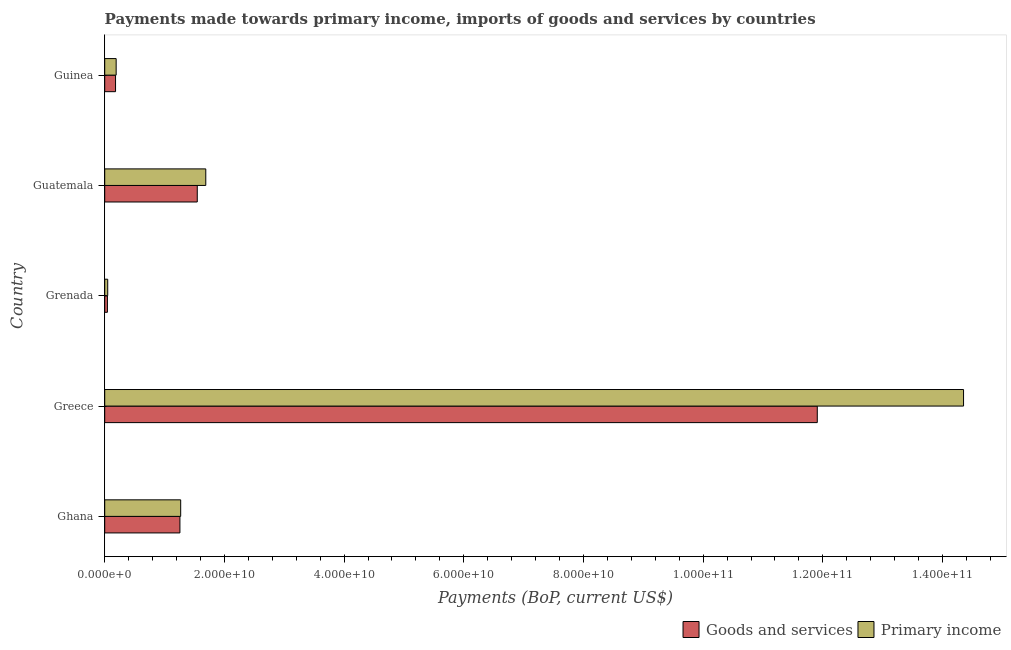How many different coloured bars are there?
Offer a terse response. 2. Are the number of bars per tick equal to the number of legend labels?
Your answer should be compact. Yes. Are the number of bars on each tick of the Y-axis equal?
Provide a short and direct response. Yes. How many bars are there on the 3rd tick from the bottom?
Ensure brevity in your answer.  2. In how many cases, is the number of bars for a given country not equal to the number of legend labels?
Your answer should be compact. 0. What is the payments made towards primary income in Greece?
Your response must be concise. 1.44e+11. Across all countries, what is the maximum payments made towards primary income?
Provide a succinct answer. 1.44e+11. Across all countries, what is the minimum payments made towards goods and services?
Offer a very short reply. 4.52e+08. In which country was the payments made towards primary income minimum?
Give a very brief answer. Grenada. What is the total payments made towards primary income in the graph?
Ensure brevity in your answer.  1.76e+11. What is the difference between the payments made towards primary income in Ghana and that in Grenada?
Your response must be concise. 1.22e+1. What is the difference between the payments made towards goods and services in Grenada and the payments made towards primary income in Greece?
Your answer should be compact. -1.43e+11. What is the average payments made towards primary income per country?
Make the answer very short. 3.51e+1. What is the difference between the payments made towards primary income and payments made towards goods and services in Guatemala?
Provide a short and direct response. 1.42e+09. What is the ratio of the payments made towards primary income in Greece to that in Guinea?
Your response must be concise. 75.08. Is the difference between the payments made towards goods and services in Ghana and Guatemala greater than the difference between the payments made towards primary income in Ghana and Guatemala?
Provide a short and direct response. Yes. What is the difference between the highest and the second highest payments made towards goods and services?
Provide a succinct answer. 1.04e+11. What is the difference between the highest and the lowest payments made towards primary income?
Ensure brevity in your answer.  1.43e+11. What does the 1st bar from the top in Ghana represents?
Ensure brevity in your answer.  Primary income. What does the 2nd bar from the bottom in Guatemala represents?
Give a very brief answer. Primary income. How many bars are there?
Offer a terse response. 10. How many legend labels are there?
Offer a terse response. 2. What is the title of the graph?
Offer a terse response. Payments made towards primary income, imports of goods and services by countries. What is the label or title of the X-axis?
Your response must be concise. Payments (BoP, current US$). What is the label or title of the Y-axis?
Offer a very short reply. Country. What is the Payments (BoP, current US$) of Goods and services in Ghana?
Ensure brevity in your answer.  1.26e+1. What is the Payments (BoP, current US$) in Primary income in Ghana?
Provide a succinct answer. 1.27e+1. What is the Payments (BoP, current US$) in Goods and services in Greece?
Provide a short and direct response. 1.19e+11. What is the Payments (BoP, current US$) in Primary income in Greece?
Offer a very short reply. 1.44e+11. What is the Payments (BoP, current US$) in Goods and services in Grenada?
Ensure brevity in your answer.  4.52e+08. What is the Payments (BoP, current US$) in Primary income in Grenada?
Ensure brevity in your answer.  5.03e+08. What is the Payments (BoP, current US$) of Goods and services in Guatemala?
Your answer should be very brief. 1.55e+1. What is the Payments (BoP, current US$) of Primary income in Guatemala?
Your response must be concise. 1.69e+1. What is the Payments (BoP, current US$) of Goods and services in Guinea?
Give a very brief answer. 1.81e+09. What is the Payments (BoP, current US$) in Primary income in Guinea?
Offer a very short reply. 1.91e+09. Across all countries, what is the maximum Payments (BoP, current US$) of Goods and services?
Offer a very short reply. 1.19e+11. Across all countries, what is the maximum Payments (BoP, current US$) in Primary income?
Your answer should be very brief. 1.44e+11. Across all countries, what is the minimum Payments (BoP, current US$) of Goods and services?
Your answer should be very brief. 4.52e+08. Across all countries, what is the minimum Payments (BoP, current US$) of Primary income?
Provide a short and direct response. 5.03e+08. What is the total Payments (BoP, current US$) in Goods and services in the graph?
Keep it short and to the point. 1.49e+11. What is the total Payments (BoP, current US$) in Primary income in the graph?
Make the answer very short. 1.76e+11. What is the difference between the Payments (BoP, current US$) in Goods and services in Ghana and that in Greece?
Your response must be concise. -1.07e+11. What is the difference between the Payments (BoP, current US$) in Primary income in Ghana and that in Greece?
Make the answer very short. -1.31e+11. What is the difference between the Payments (BoP, current US$) of Goods and services in Ghana and that in Grenada?
Provide a succinct answer. 1.21e+1. What is the difference between the Payments (BoP, current US$) in Primary income in Ghana and that in Grenada?
Provide a succinct answer. 1.22e+1. What is the difference between the Payments (BoP, current US$) in Goods and services in Ghana and that in Guatemala?
Your answer should be compact. -2.90e+09. What is the difference between the Payments (BoP, current US$) in Primary income in Ghana and that in Guatemala?
Your answer should be very brief. -4.19e+09. What is the difference between the Payments (BoP, current US$) in Goods and services in Ghana and that in Guinea?
Keep it short and to the point. 1.08e+1. What is the difference between the Payments (BoP, current US$) of Primary income in Ghana and that in Guinea?
Your answer should be very brief. 1.08e+1. What is the difference between the Payments (BoP, current US$) of Goods and services in Greece and that in Grenada?
Your response must be concise. 1.19e+11. What is the difference between the Payments (BoP, current US$) in Primary income in Greece and that in Grenada?
Offer a very short reply. 1.43e+11. What is the difference between the Payments (BoP, current US$) of Goods and services in Greece and that in Guatemala?
Ensure brevity in your answer.  1.04e+11. What is the difference between the Payments (BoP, current US$) in Primary income in Greece and that in Guatemala?
Keep it short and to the point. 1.27e+11. What is the difference between the Payments (BoP, current US$) of Goods and services in Greece and that in Guinea?
Your answer should be compact. 1.17e+11. What is the difference between the Payments (BoP, current US$) in Primary income in Greece and that in Guinea?
Ensure brevity in your answer.  1.42e+11. What is the difference between the Payments (BoP, current US$) of Goods and services in Grenada and that in Guatemala?
Your response must be concise. -1.50e+1. What is the difference between the Payments (BoP, current US$) of Primary income in Grenada and that in Guatemala?
Ensure brevity in your answer.  -1.64e+1. What is the difference between the Payments (BoP, current US$) in Goods and services in Grenada and that in Guinea?
Make the answer very short. -1.36e+09. What is the difference between the Payments (BoP, current US$) in Primary income in Grenada and that in Guinea?
Offer a very short reply. -1.41e+09. What is the difference between the Payments (BoP, current US$) in Goods and services in Guatemala and that in Guinea?
Your answer should be compact. 1.37e+1. What is the difference between the Payments (BoP, current US$) of Primary income in Guatemala and that in Guinea?
Provide a short and direct response. 1.50e+1. What is the difference between the Payments (BoP, current US$) of Goods and services in Ghana and the Payments (BoP, current US$) of Primary income in Greece?
Your answer should be very brief. -1.31e+11. What is the difference between the Payments (BoP, current US$) in Goods and services in Ghana and the Payments (BoP, current US$) in Primary income in Grenada?
Make the answer very short. 1.21e+1. What is the difference between the Payments (BoP, current US$) in Goods and services in Ghana and the Payments (BoP, current US$) in Primary income in Guatemala?
Offer a terse response. -4.32e+09. What is the difference between the Payments (BoP, current US$) in Goods and services in Ghana and the Payments (BoP, current US$) in Primary income in Guinea?
Ensure brevity in your answer.  1.07e+1. What is the difference between the Payments (BoP, current US$) of Goods and services in Greece and the Payments (BoP, current US$) of Primary income in Grenada?
Provide a succinct answer. 1.19e+11. What is the difference between the Payments (BoP, current US$) in Goods and services in Greece and the Payments (BoP, current US$) in Primary income in Guatemala?
Your answer should be compact. 1.02e+11. What is the difference between the Payments (BoP, current US$) of Goods and services in Greece and the Payments (BoP, current US$) of Primary income in Guinea?
Make the answer very short. 1.17e+11. What is the difference between the Payments (BoP, current US$) in Goods and services in Grenada and the Payments (BoP, current US$) in Primary income in Guatemala?
Offer a very short reply. -1.64e+1. What is the difference between the Payments (BoP, current US$) of Goods and services in Grenada and the Payments (BoP, current US$) of Primary income in Guinea?
Offer a terse response. -1.46e+09. What is the difference between the Payments (BoP, current US$) of Goods and services in Guatemala and the Payments (BoP, current US$) of Primary income in Guinea?
Your response must be concise. 1.36e+1. What is the average Payments (BoP, current US$) of Goods and services per country?
Your answer should be compact. 2.99e+1. What is the average Payments (BoP, current US$) of Primary income per country?
Your answer should be very brief. 3.51e+1. What is the difference between the Payments (BoP, current US$) of Goods and services and Payments (BoP, current US$) of Primary income in Ghana?
Your answer should be compact. -1.29e+08. What is the difference between the Payments (BoP, current US$) of Goods and services and Payments (BoP, current US$) of Primary income in Greece?
Keep it short and to the point. -2.44e+1. What is the difference between the Payments (BoP, current US$) of Goods and services and Payments (BoP, current US$) of Primary income in Grenada?
Make the answer very short. -5.08e+07. What is the difference between the Payments (BoP, current US$) of Goods and services and Payments (BoP, current US$) of Primary income in Guatemala?
Your response must be concise. -1.42e+09. What is the difference between the Payments (BoP, current US$) of Goods and services and Payments (BoP, current US$) of Primary income in Guinea?
Offer a very short reply. -1.01e+08. What is the ratio of the Payments (BoP, current US$) of Goods and services in Ghana to that in Greece?
Provide a short and direct response. 0.11. What is the ratio of the Payments (BoP, current US$) of Primary income in Ghana to that in Greece?
Give a very brief answer. 0.09. What is the ratio of the Payments (BoP, current US$) in Goods and services in Ghana to that in Grenada?
Offer a very short reply. 27.82. What is the ratio of the Payments (BoP, current US$) of Primary income in Ghana to that in Grenada?
Your answer should be very brief. 25.26. What is the ratio of the Payments (BoP, current US$) of Goods and services in Ghana to that in Guatemala?
Provide a succinct answer. 0.81. What is the ratio of the Payments (BoP, current US$) of Primary income in Ghana to that in Guatemala?
Give a very brief answer. 0.75. What is the ratio of the Payments (BoP, current US$) in Goods and services in Ghana to that in Guinea?
Offer a very short reply. 6.94. What is the ratio of the Payments (BoP, current US$) of Primary income in Ghana to that in Guinea?
Ensure brevity in your answer.  6.64. What is the ratio of the Payments (BoP, current US$) in Goods and services in Greece to that in Grenada?
Your answer should be very brief. 263.58. What is the ratio of the Payments (BoP, current US$) of Primary income in Greece to that in Grenada?
Your answer should be very brief. 285.58. What is the ratio of the Payments (BoP, current US$) in Goods and services in Greece to that in Guatemala?
Provide a short and direct response. 7.7. What is the ratio of the Payments (BoP, current US$) of Primary income in Greece to that in Guatemala?
Provide a succinct answer. 8.5. What is the ratio of the Payments (BoP, current US$) in Goods and services in Greece to that in Guinea?
Your answer should be compact. 65.77. What is the ratio of the Payments (BoP, current US$) in Primary income in Greece to that in Guinea?
Provide a short and direct response. 75.08. What is the ratio of the Payments (BoP, current US$) of Goods and services in Grenada to that in Guatemala?
Provide a succinct answer. 0.03. What is the ratio of the Payments (BoP, current US$) of Primary income in Grenada to that in Guatemala?
Provide a short and direct response. 0.03. What is the ratio of the Payments (BoP, current US$) of Goods and services in Grenada to that in Guinea?
Keep it short and to the point. 0.25. What is the ratio of the Payments (BoP, current US$) in Primary income in Grenada to that in Guinea?
Provide a short and direct response. 0.26. What is the ratio of the Payments (BoP, current US$) in Goods and services in Guatemala to that in Guinea?
Ensure brevity in your answer.  8.54. What is the ratio of the Payments (BoP, current US$) in Primary income in Guatemala to that in Guinea?
Your answer should be very brief. 8.84. What is the difference between the highest and the second highest Payments (BoP, current US$) in Goods and services?
Give a very brief answer. 1.04e+11. What is the difference between the highest and the second highest Payments (BoP, current US$) of Primary income?
Give a very brief answer. 1.27e+11. What is the difference between the highest and the lowest Payments (BoP, current US$) of Goods and services?
Offer a terse response. 1.19e+11. What is the difference between the highest and the lowest Payments (BoP, current US$) in Primary income?
Offer a terse response. 1.43e+11. 